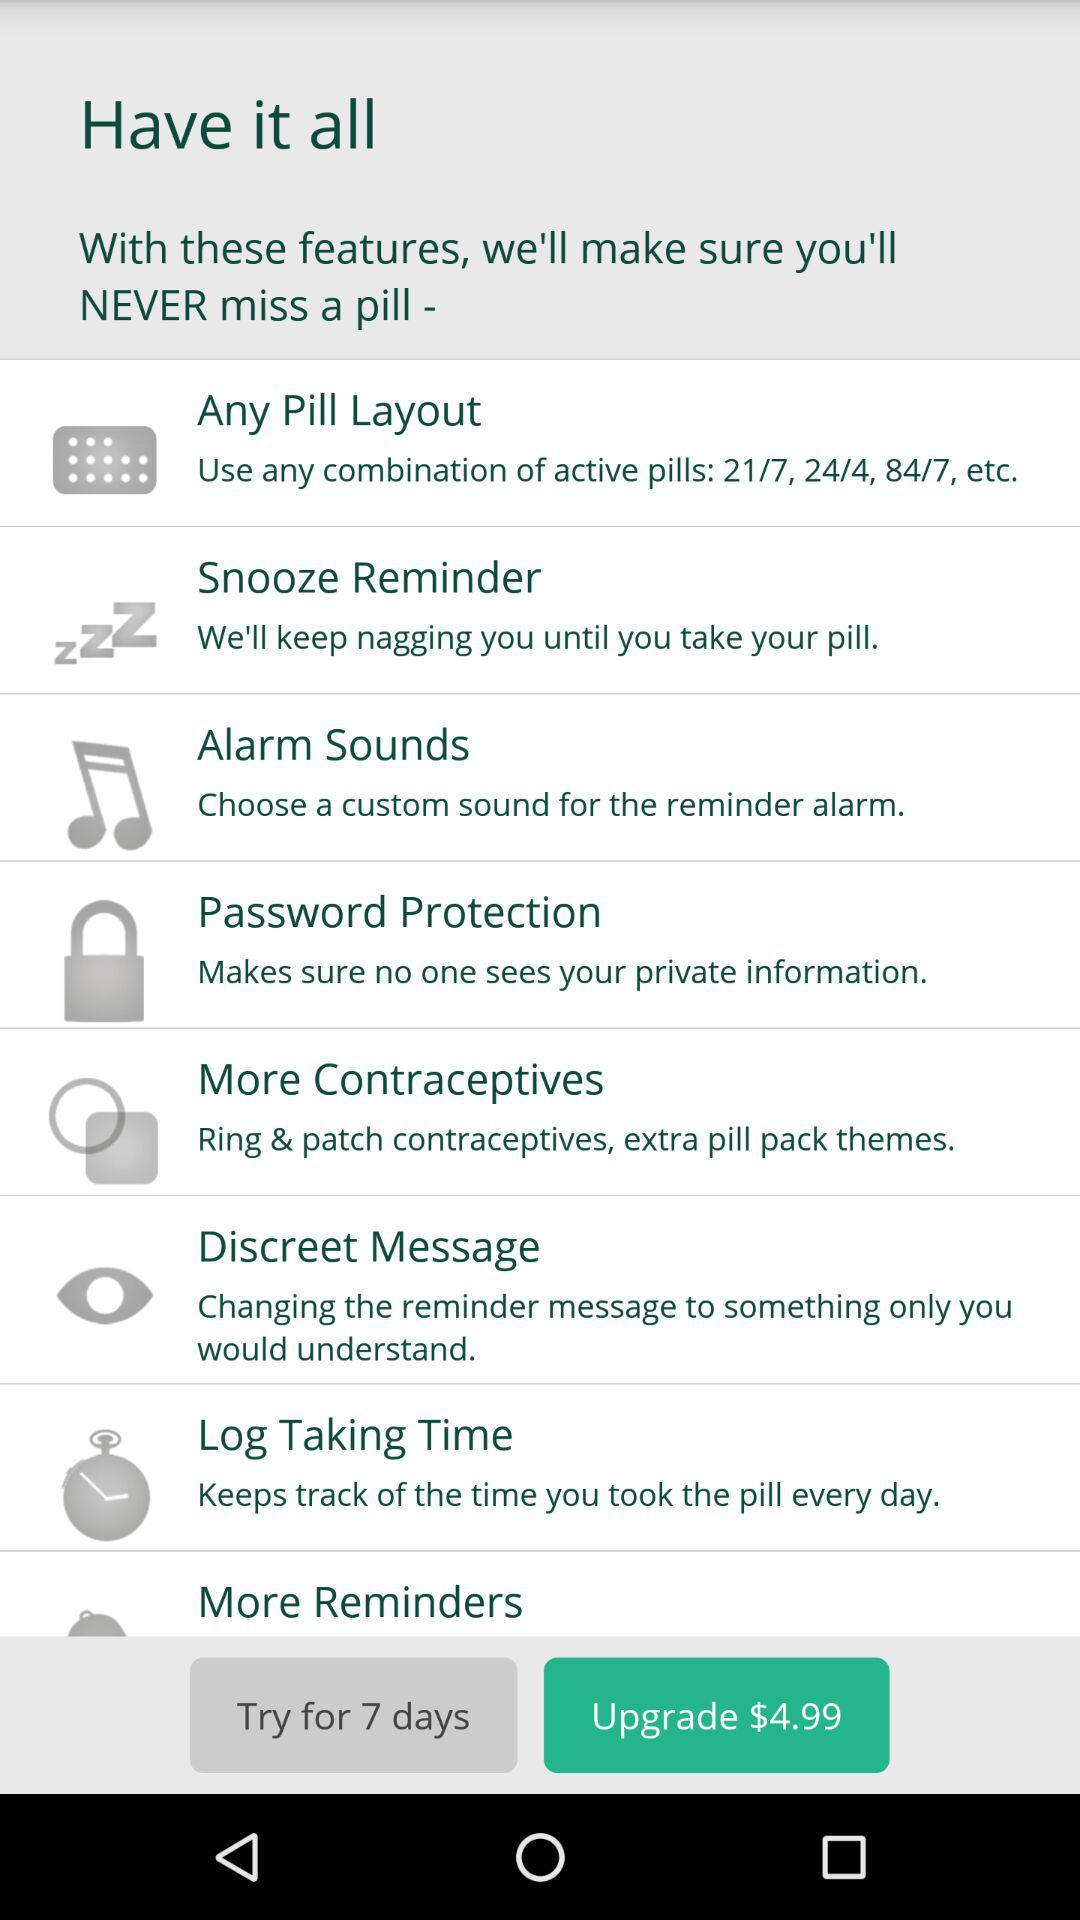What's the upgrade price? The upgrade price is $4.99. 